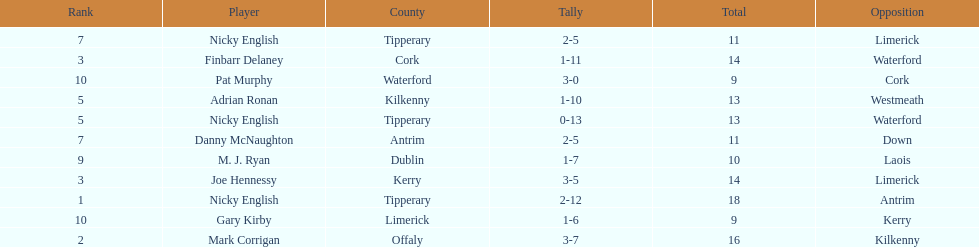Who was the top ranked player in a single game? Nicky English. 